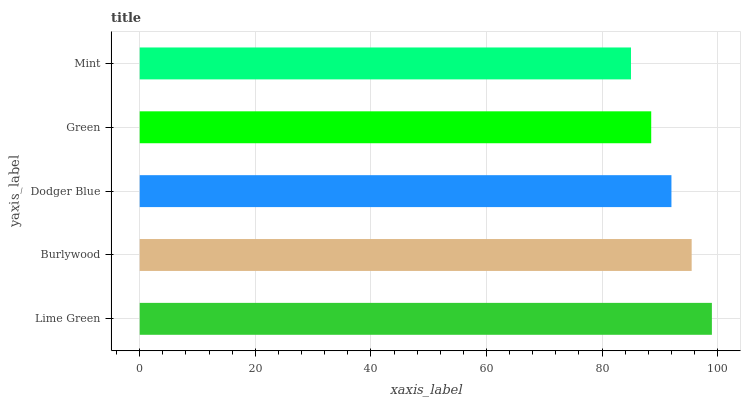Is Mint the minimum?
Answer yes or no. Yes. Is Lime Green the maximum?
Answer yes or no. Yes. Is Burlywood the minimum?
Answer yes or no. No. Is Burlywood the maximum?
Answer yes or no. No. Is Lime Green greater than Burlywood?
Answer yes or no. Yes. Is Burlywood less than Lime Green?
Answer yes or no. Yes. Is Burlywood greater than Lime Green?
Answer yes or no. No. Is Lime Green less than Burlywood?
Answer yes or no. No. Is Dodger Blue the high median?
Answer yes or no. Yes. Is Dodger Blue the low median?
Answer yes or no. Yes. Is Burlywood the high median?
Answer yes or no. No. Is Lime Green the low median?
Answer yes or no. No. 